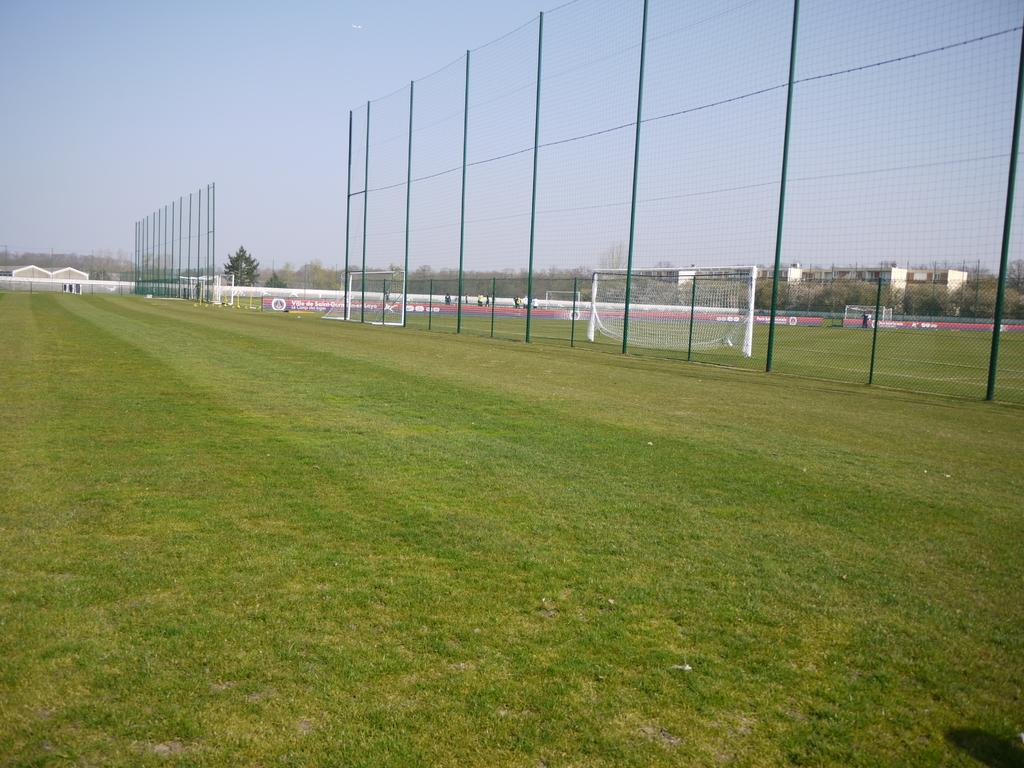What type of vegetation is present on the ground in the front of the image? There is grass on the ground in the front of the image. What structure can be seen in the center of the image? There is a fence in the center of the image. What can be seen in the background of the image? There are trees and buildings in the background of the image. How many brothers are visible in the image? There are no brothers present in the image. What type of wool is used to make the fence in the image? There is no wool used to make the fence in the image; it is likely made of wood or metal. 